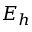<formula> <loc_0><loc_0><loc_500><loc_500>E _ { h }</formula> 